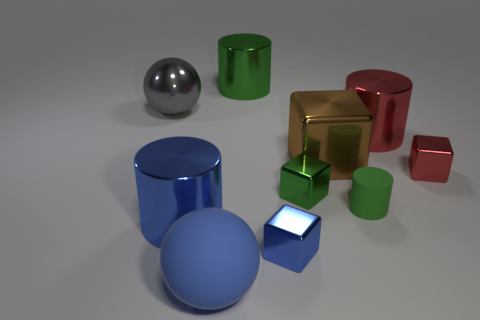Is there anything else of the same color as the big cube?
Make the answer very short. No. The small rubber object has what color?
Your response must be concise. Green. Do the metal thing that is behind the gray object and the matte object that is behind the big blue cylinder have the same color?
Ensure brevity in your answer.  Yes. The red metallic cube is what size?
Your response must be concise. Small. What size is the ball that is in front of the large blue metal cylinder?
Your answer should be compact. Large. What is the shape of the big metallic thing that is both to the left of the big brown metallic object and right of the big blue metal cylinder?
Offer a very short reply. Cylinder. What number of other things are there of the same shape as the tiny blue metallic object?
Your response must be concise. 3. The shiny sphere that is the same size as the blue matte thing is what color?
Offer a very short reply. Gray. What number of things are large red shiny cylinders or brown metal objects?
Offer a terse response. 2. There is a large shiny block; are there any big red things behind it?
Your answer should be very brief. Yes. 